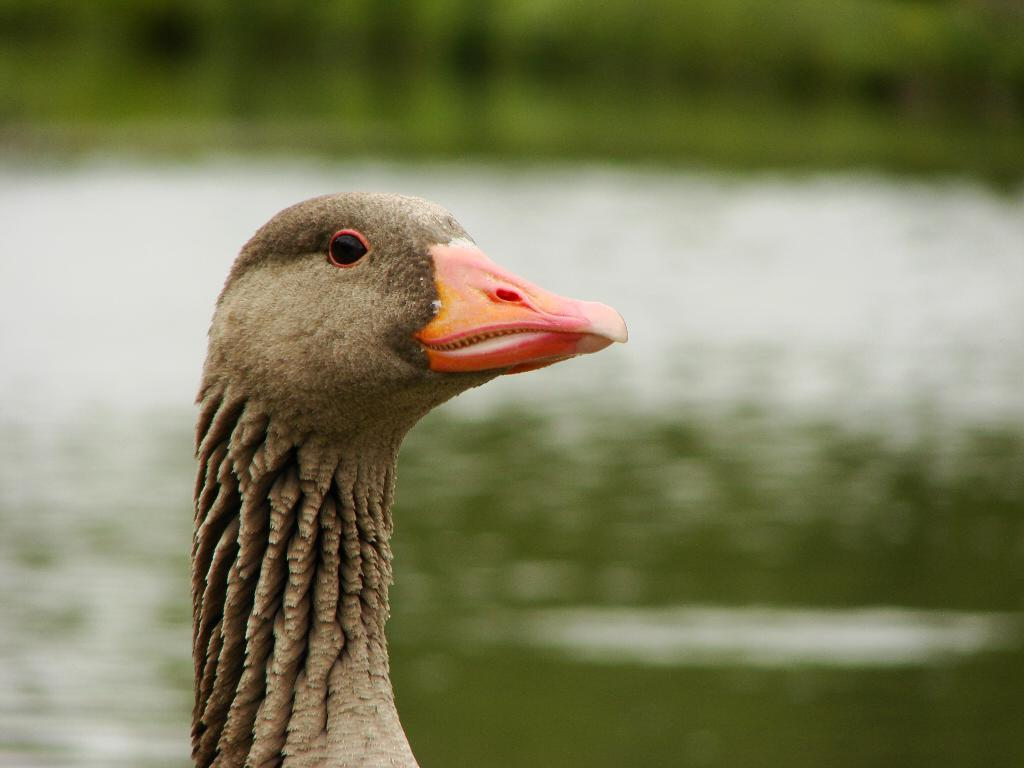What type of animal can be seen in the image? There is a bird in the image. What can be seen in the background of the image? There is water visible in the background of the image. What color is the cat in the image? There is no cat present in the image; it features a bird and water in the background. 